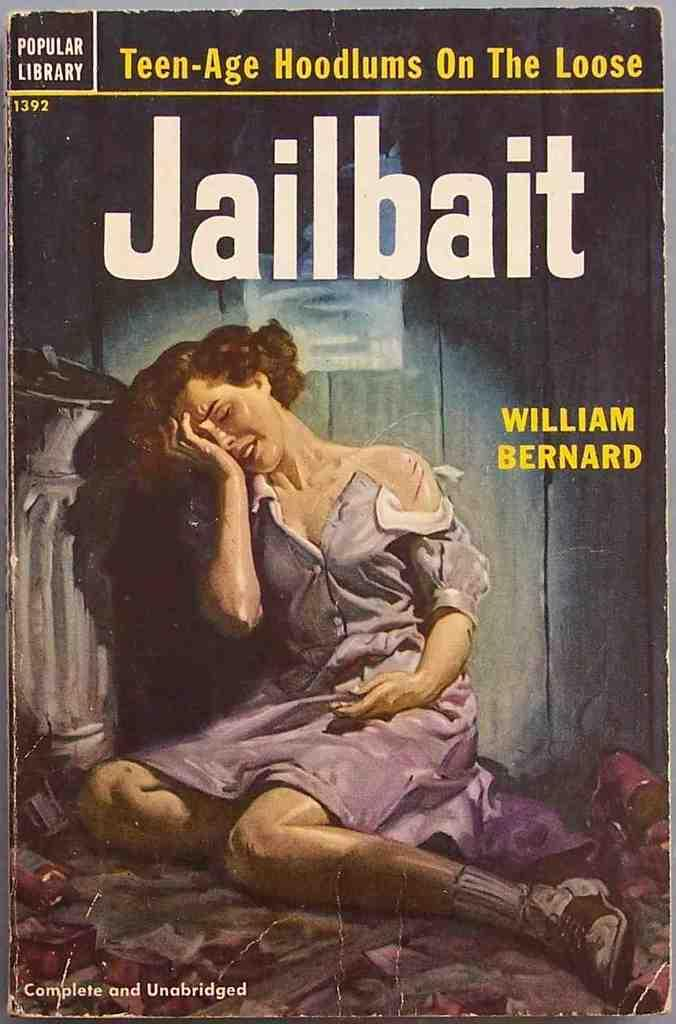<image>
Share a concise interpretation of the image provided. A book by William Bernard has a woman on the cover. 